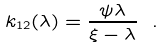<formula> <loc_0><loc_0><loc_500><loc_500>k _ { 1 2 } ( \lambda ) = \frac { \psi \lambda } { \xi - \lambda } \ .</formula> 